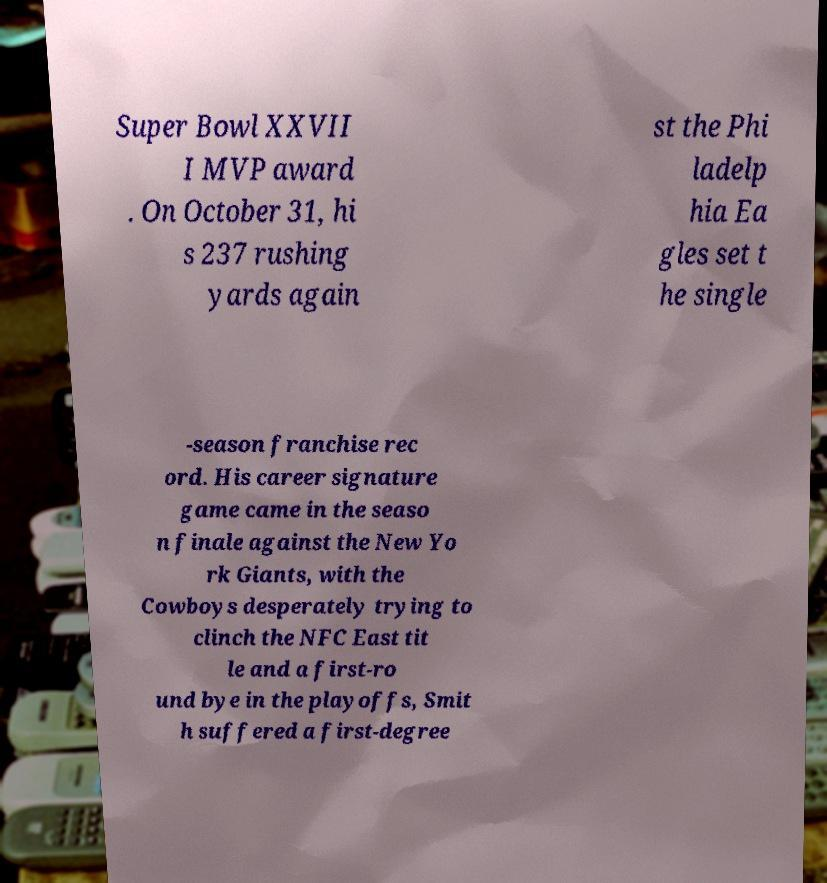Can you accurately transcribe the text from the provided image for me? Super Bowl XXVII I MVP award . On October 31, hi s 237 rushing yards again st the Phi ladelp hia Ea gles set t he single -season franchise rec ord. His career signature game came in the seaso n finale against the New Yo rk Giants, with the Cowboys desperately trying to clinch the NFC East tit le and a first-ro und bye in the playoffs, Smit h suffered a first-degree 